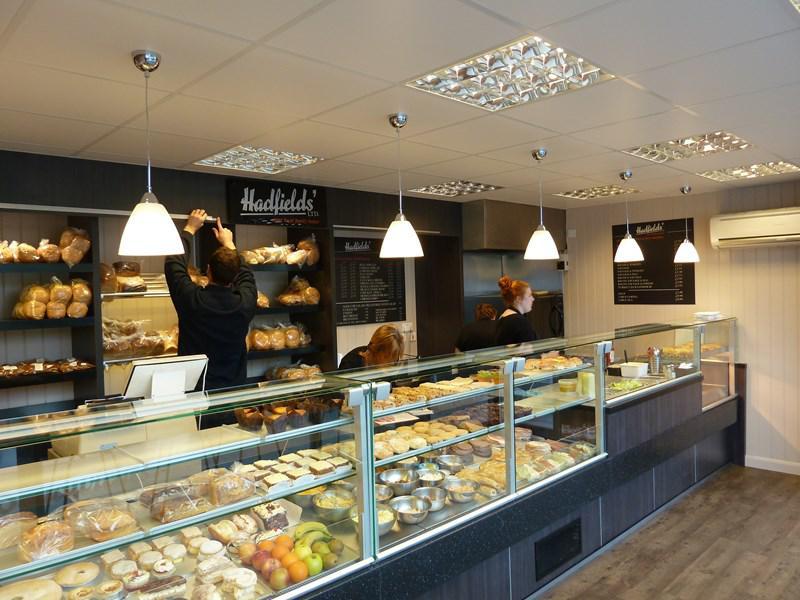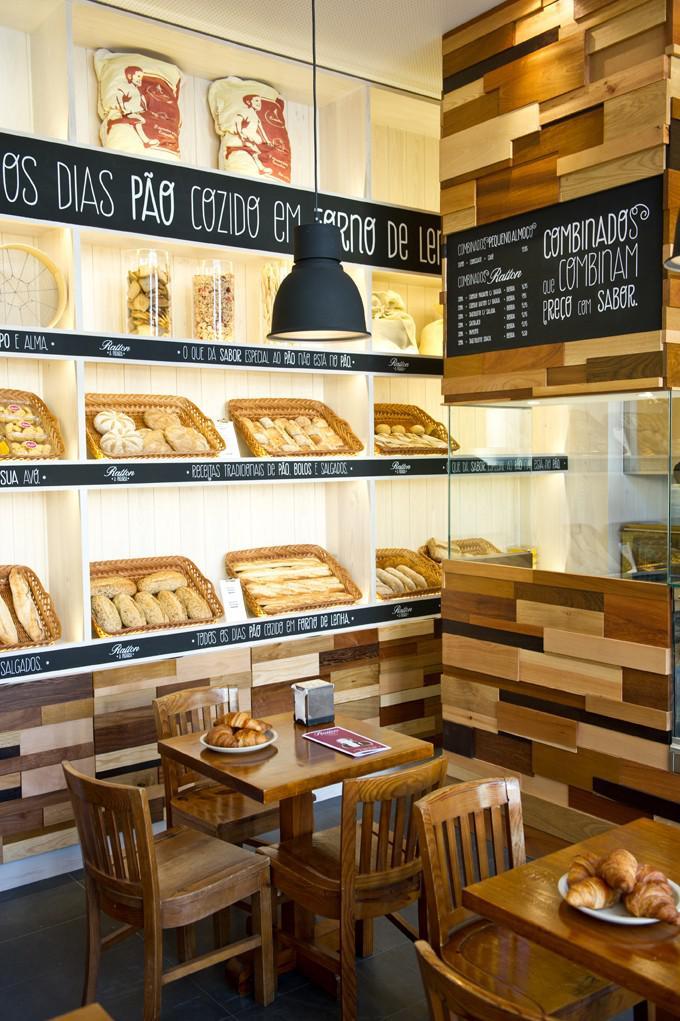The first image is the image on the left, the second image is the image on the right. Evaluate the accuracy of this statement regarding the images: "People are standing near a case of baked goods". Is it true? Answer yes or no. Yes. The first image is the image on the left, the second image is the image on the right. Evaluate the accuracy of this statement regarding the images: "At least five pendant lights hang over one of the bakery display images.". Is it true? Answer yes or no. Yes. 